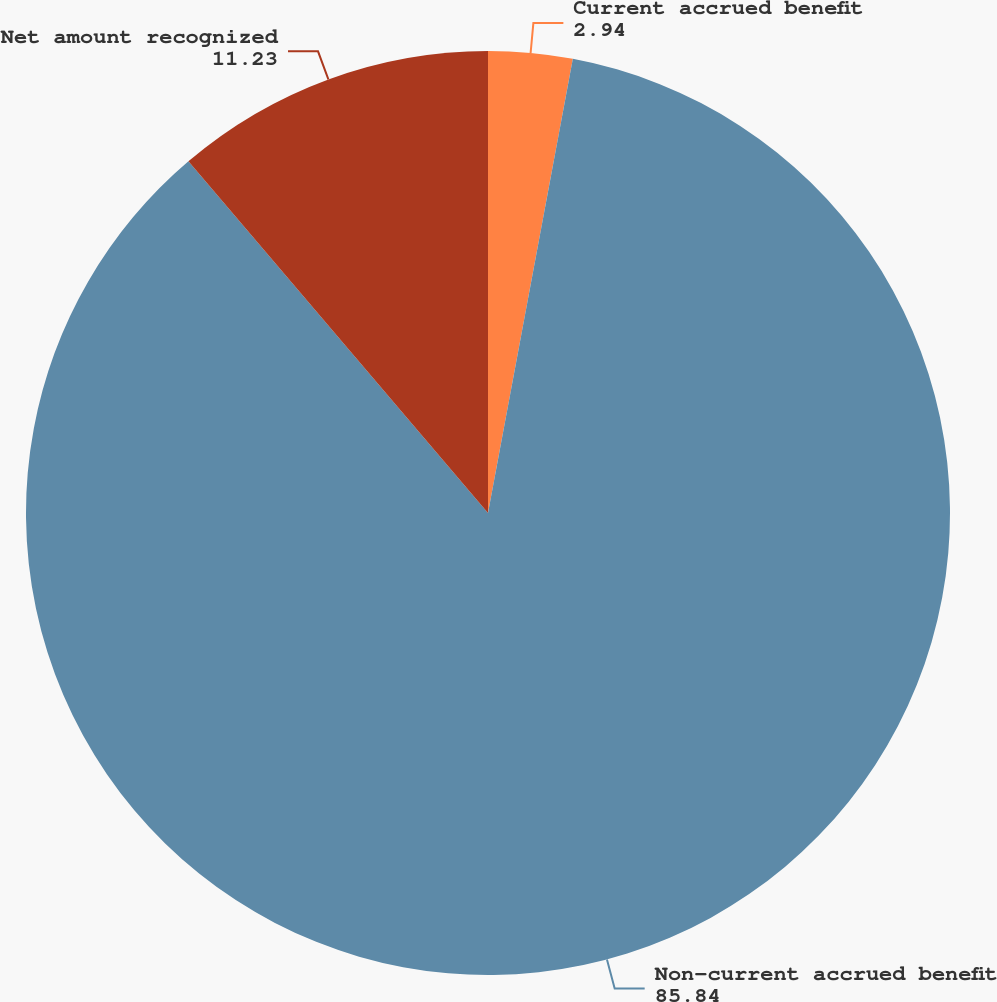<chart> <loc_0><loc_0><loc_500><loc_500><pie_chart><fcel>Current accrued benefit<fcel>Non-current accrued benefit<fcel>Net amount recognized<nl><fcel>2.94%<fcel>85.84%<fcel>11.23%<nl></chart> 